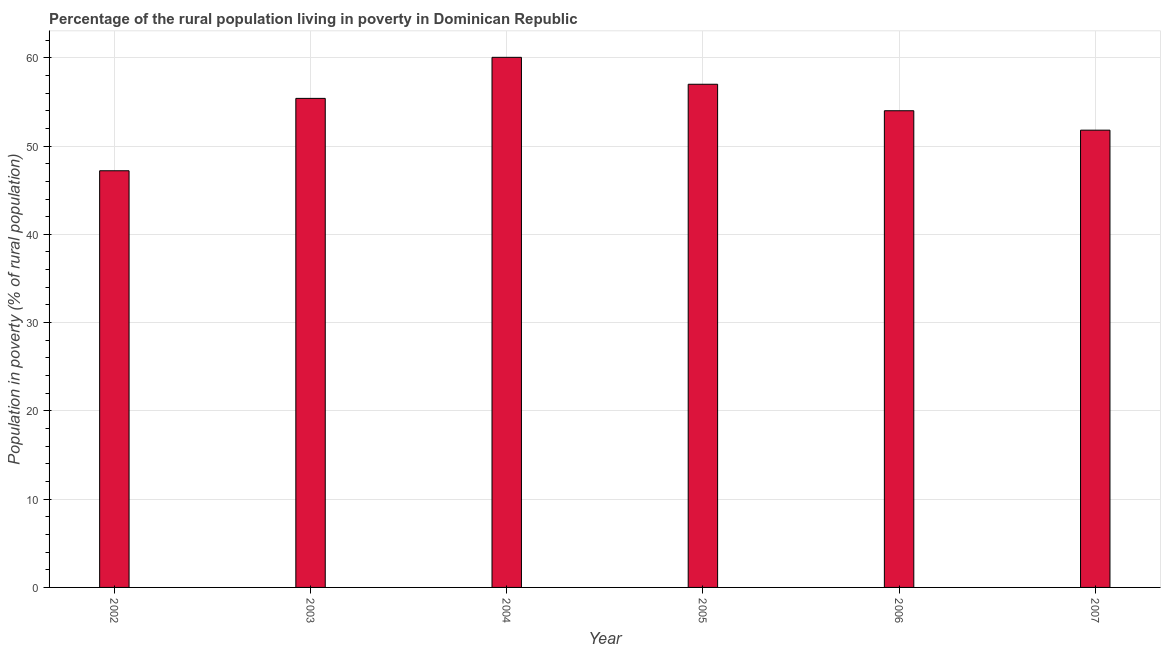What is the title of the graph?
Give a very brief answer. Percentage of the rural population living in poverty in Dominican Republic. What is the label or title of the Y-axis?
Give a very brief answer. Population in poverty (% of rural population). Across all years, what is the maximum percentage of rural population living below poverty line?
Offer a terse response. 60.05. Across all years, what is the minimum percentage of rural population living below poverty line?
Make the answer very short. 47.2. In which year was the percentage of rural population living below poverty line maximum?
Give a very brief answer. 2004. What is the sum of the percentage of rural population living below poverty line?
Your response must be concise. 325.45. What is the difference between the percentage of rural population living below poverty line in 2002 and 2003?
Ensure brevity in your answer.  -8.2. What is the average percentage of rural population living below poverty line per year?
Provide a short and direct response. 54.24. What is the median percentage of rural population living below poverty line?
Make the answer very short. 54.7. Do a majority of the years between 2003 and 2004 (inclusive) have percentage of rural population living below poverty line greater than 34 %?
Your answer should be compact. Yes. What is the ratio of the percentage of rural population living below poverty line in 2004 to that in 2006?
Your response must be concise. 1.11. Is the percentage of rural population living below poverty line in 2002 less than that in 2005?
Keep it short and to the point. Yes. What is the difference between the highest and the second highest percentage of rural population living below poverty line?
Make the answer very short. 3.05. What is the difference between the highest and the lowest percentage of rural population living below poverty line?
Keep it short and to the point. 12.85. How many bars are there?
Ensure brevity in your answer.  6. How many years are there in the graph?
Provide a succinct answer. 6. What is the difference between two consecutive major ticks on the Y-axis?
Give a very brief answer. 10. What is the Population in poverty (% of rural population) in 2002?
Your response must be concise. 47.2. What is the Population in poverty (% of rural population) of 2003?
Your response must be concise. 55.4. What is the Population in poverty (% of rural population) in 2004?
Offer a very short reply. 60.05. What is the Population in poverty (% of rural population) in 2005?
Provide a short and direct response. 57. What is the Population in poverty (% of rural population) of 2007?
Keep it short and to the point. 51.8. What is the difference between the Population in poverty (% of rural population) in 2002 and 2004?
Your response must be concise. -12.85. What is the difference between the Population in poverty (% of rural population) in 2002 and 2006?
Provide a succinct answer. -6.8. What is the difference between the Population in poverty (% of rural population) in 2002 and 2007?
Your response must be concise. -4.6. What is the difference between the Population in poverty (% of rural population) in 2003 and 2004?
Keep it short and to the point. -4.65. What is the difference between the Population in poverty (% of rural population) in 2003 and 2005?
Your answer should be compact. -1.6. What is the difference between the Population in poverty (% of rural population) in 2003 and 2006?
Make the answer very short. 1.4. What is the difference between the Population in poverty (% of rural population) in 2003 and 2007?
Your answer should be compact. 3.6. What is the difference between the Population in poverty (% of rural population) in 2004 and 2005?
Make the answer very short. 3.05. What is the difference between the Population in poverty (% of rural population) in 2004 and 2006?
Offer a very short reply. 6.05. What is the difference between the Population in poverty (% of rural population) in 2004 and 2007?
Provide a succinct answer. 8.25. What is the difference between the Population in poverty (% of rural population) in 2005 and 2007?
Give a very brief answer. 5.2. What is the difference between the Population in poverty (% of rural population) in 2006 and 2007?
Offer a very short reply. 2.2. What is the ratio of the Population in poverty (% of rural population) in 2002 to that in 2003?
Provide a succinct answer. 0.85. What is the ratio of the Population in poverty (% of rural population) in 2002 to that in 2004?
Give a very brief answer. 0.79. What is the ratio of the Population in poverty (% of rural population) in 2002 to that in 2005?
Offer a terse response. 0.83. What is the ratio of the Population in poverty (% of rural population) in 2002 to that in 2006?
Offer a terse response. 0.87. What is the ratio of the Population in poverty (% of rural population) in 2002 to that in 2007?
Your answer should be compact. 0.91. What is the ratio of the Population in poverty (% of rural population) in 2003 to that in 2004?
Provide a succinct answer. 0.92. What is the ratio of the Population in poverty (% of rural population) in 2003 to that in 2006?
Give a very brief answer. 1.03. What is the ratio of the Population in poverty (% of rural population) in 2003 to that in 2007?
Provide a short and direct response. 1.07. What is the ratio of the Population in poverty (% of rural population) in 2004 to that in 2005?
Offer a very short reply. 1.05. What is the ratio of the Population in poverty (% of rural population) in 2004 to that in 2006?
Offer a very short reply. 1.11. What is the ratio of the Population in poverty (% of rural population) in 2004 to that in 2007?
Offer a terse response. 1.16. What is the ratio of the Population in poverty (% of rural population) in 2005 to that in 2006?
Ensure brevity in your answer.  1.06. What is the ratio of the Population in poverty (% of rural population) in 2006 to that in 2007?
Ensure brevity in your answer.  1.04. 